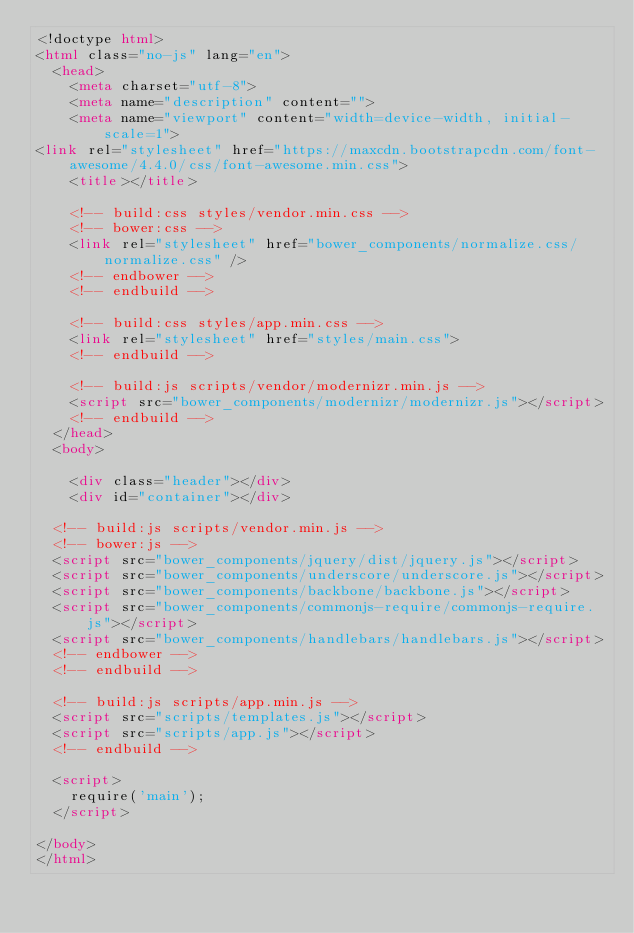Convert code to text. <code><loc_0><loc_0><loc_500><loc_500><_HTML_><!doctype html>
<html class="no-js" lang="en">
  <head>
    <meta charset="utf-8">
    <meta name="description" content="">
    <meta name="viewport" content="width=device-width, initial-scale=1">
<link rel="stylesheet" href="https://maxcdn.bootstrapcdn.com/font-awesome/4.4.0/css/font-awesome.min.css">
    <title></title>

    <!-- build:css styles/vendor.min.css -->
    <!-- bower:css -->
    <link rel="stylesheet" href="bower_components/normalize.css/normalize.css" />
    <!-- endbower -->
    <!-- endbuild -->

    <!-- build:css styles/app.min.css -->
    <link rel="stylesheet" href="styles/main.css">
    <!-- endbuild -->

    <!-- build:js scripts/vendor/modernizr.min.js -->
    <script src="bower_components/modernizr/modernizr.js"></script>
    <!-- endbuild -->
  </head>
  <body>

    <div class="header"></div>
    <div id="container"></div>

  <!-- build:js scripts/vendor.min.js -->
  <!-- bower:js -->
  <script src="bower_components/jquery/dist/jquery.js"></script>
  <script src="bower_components/underscore/underscore.js"></script>
  <script src="bower_components/backbone/backbone.js"></script>
  <script src="bower_components/commonjs-require/commonjs-require.js"></script>
  <script src="bower_components/handlebars/handlebars.js"></script>
  <!-- endbower -->
  <!-- endbuild -->

  <!-- build:js scripts/app.min.js -->
  <script src="scripts/templates.js"></script>
  <script src="scripts/app.js"></script>
  <!-- endbuild -->

  <script>
    require('main');
  </script>

</body>
</html>
</code> 